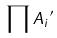<formula> <loc_0><loc_0><loc_500><loc_500>\prod { A _ { i } } ^ { \prime }</formula> 